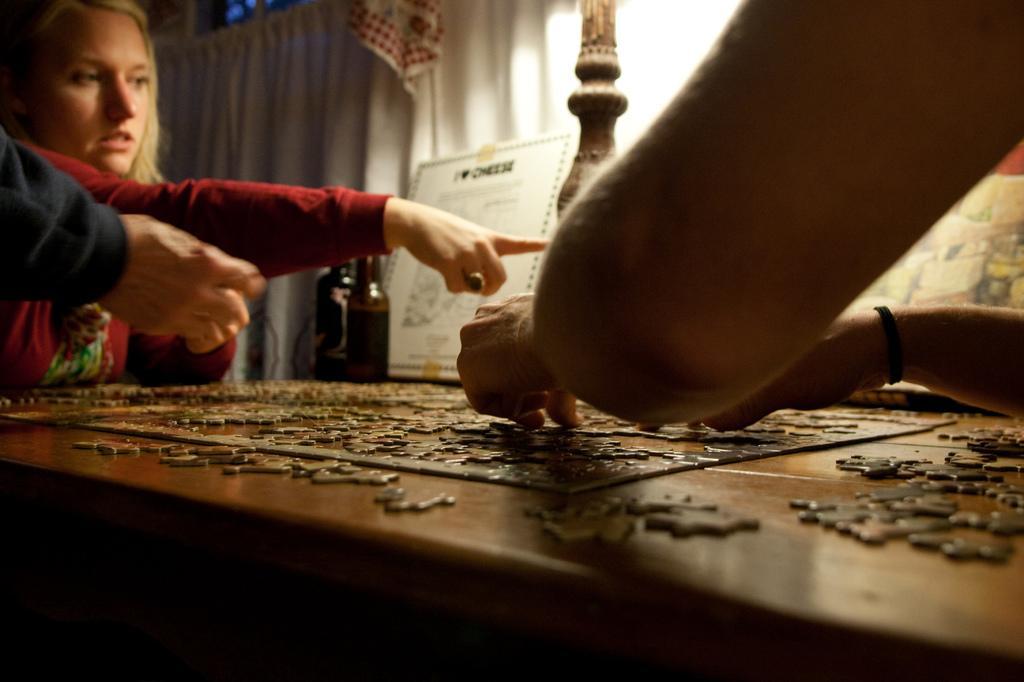Can you describe this image briefly? In this image there are three persons, below them there is a table, on that table there is a puzzle game, in the background there is a curtain. 